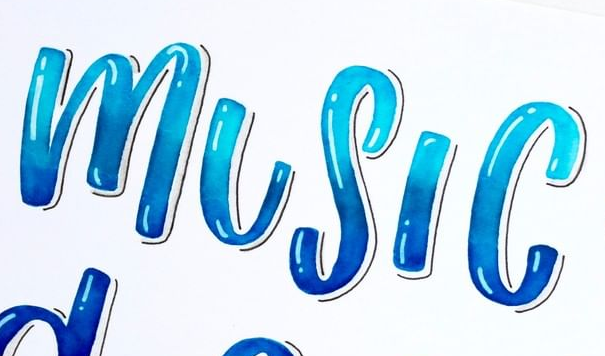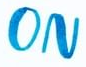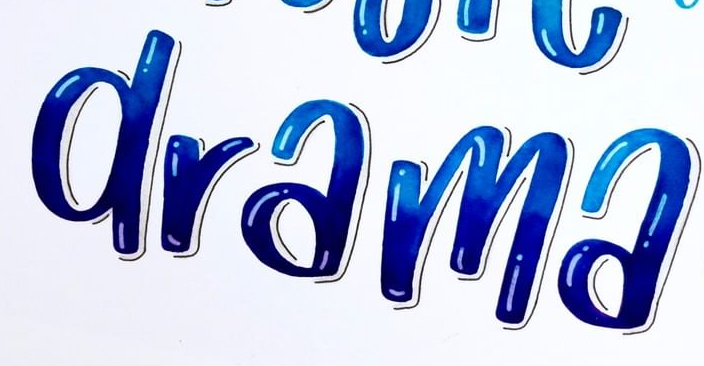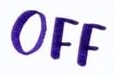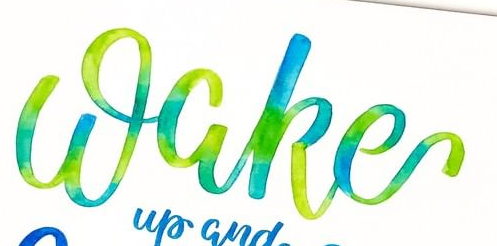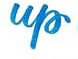Identify the words shown in these images in order, separated by a semicolon. MUSIC; ON; drama; OFF; Wake; up 